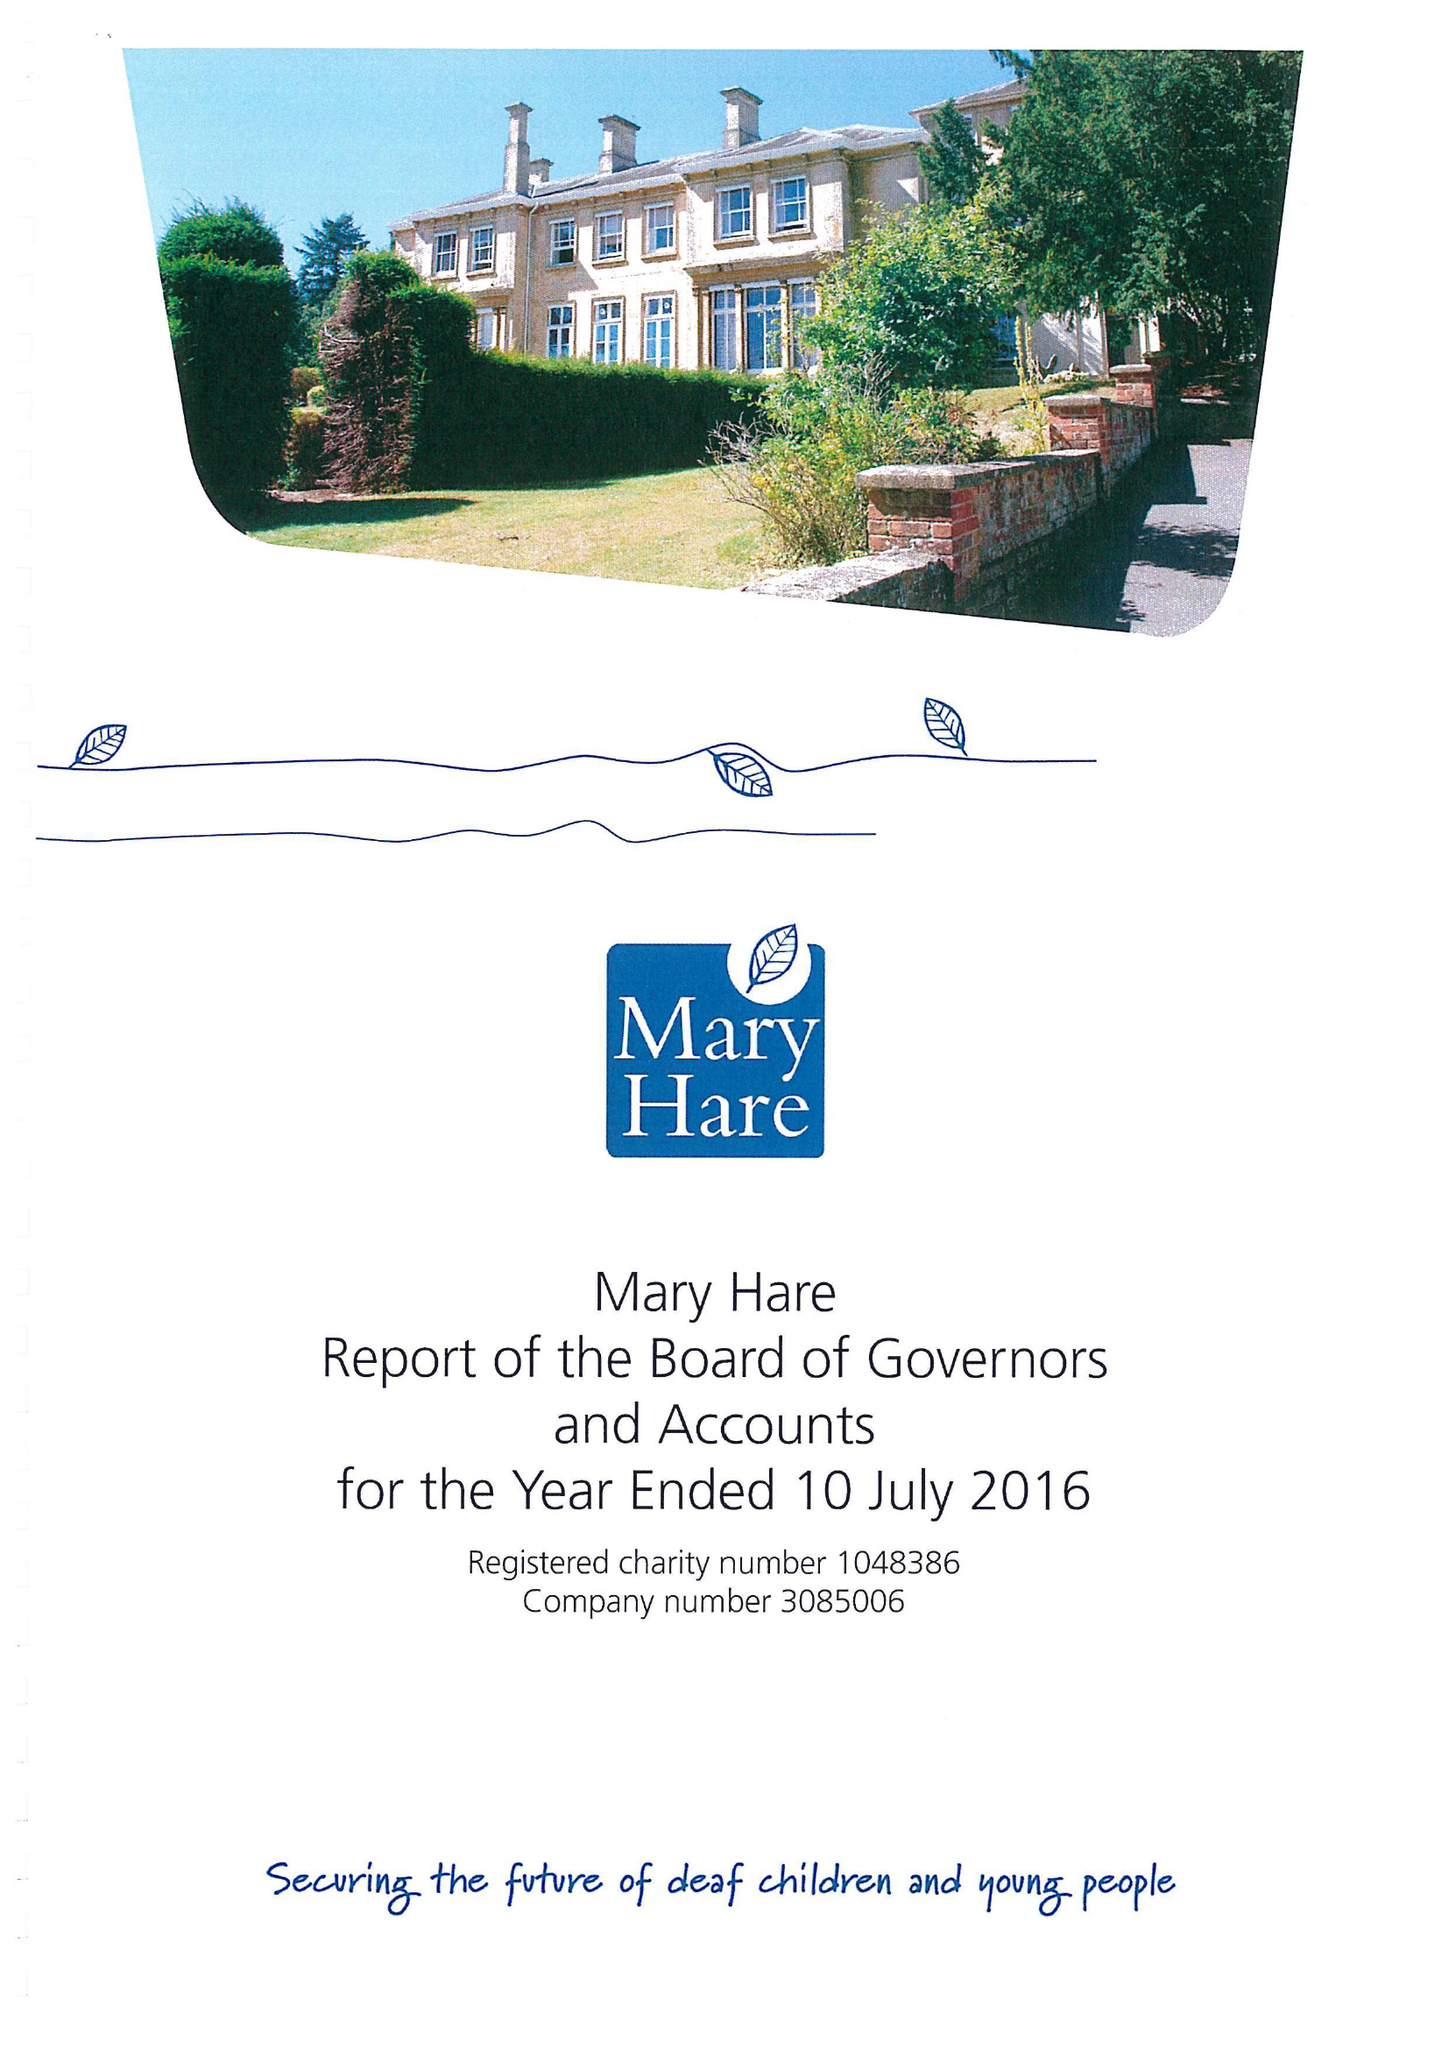What is the value for the charity_name?
Answer the question using a single word or phrase. Mary Hare 